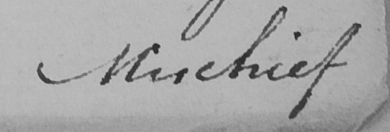Transcribe the text shown in this historical manuscript line. Mischief 